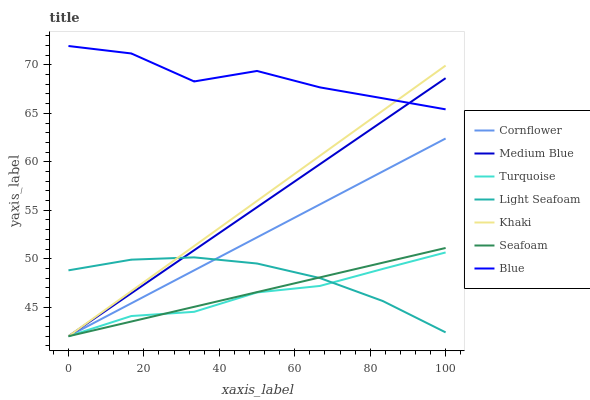Does Turquoise have the minimum area under the curve?
Answer yes or no. Yes. Does Blue have the maximum area under the curve?
Answer yes or no. Yes. Does Cornflower have the minimum area under the curve?
Answer yes or no. No. Does Cornflower have the maximum area under the curve?
Answer yes or no. No. Is Cornflower the smoothest?
Answer yes or no. Yes. Is Blue the roughest?
Answer yes or no. Yes. Is Turquoise the smoothest?
Answer yes or no. No. Is Turquoise the roughest?
Answer yes or no. No. Does Cornflower have the lowest value?
Answer yes or no. Yes. Does Light Seafoam have the lowest value?
Answer yes or no. No. Does Blue have the highest value?
Answer yes or no. Yes. Does Cornflower have the highest value?
Answer yes or no. No. Is Turquoise less than Blue?
Answer yes or no. Yes. Is Blue greater than Cornflower?
Answer yes or no. Yes. Does Medium Blue intersect Khaki?
Answer yes or no. Yes. Is Medium Blue less than Khaki?
Answer yes or no. No. Is Medium Blue greater than Khaki?
Answer yes or no. No. Does Turquoise intersect Blue?
Answer yes or no. No. 